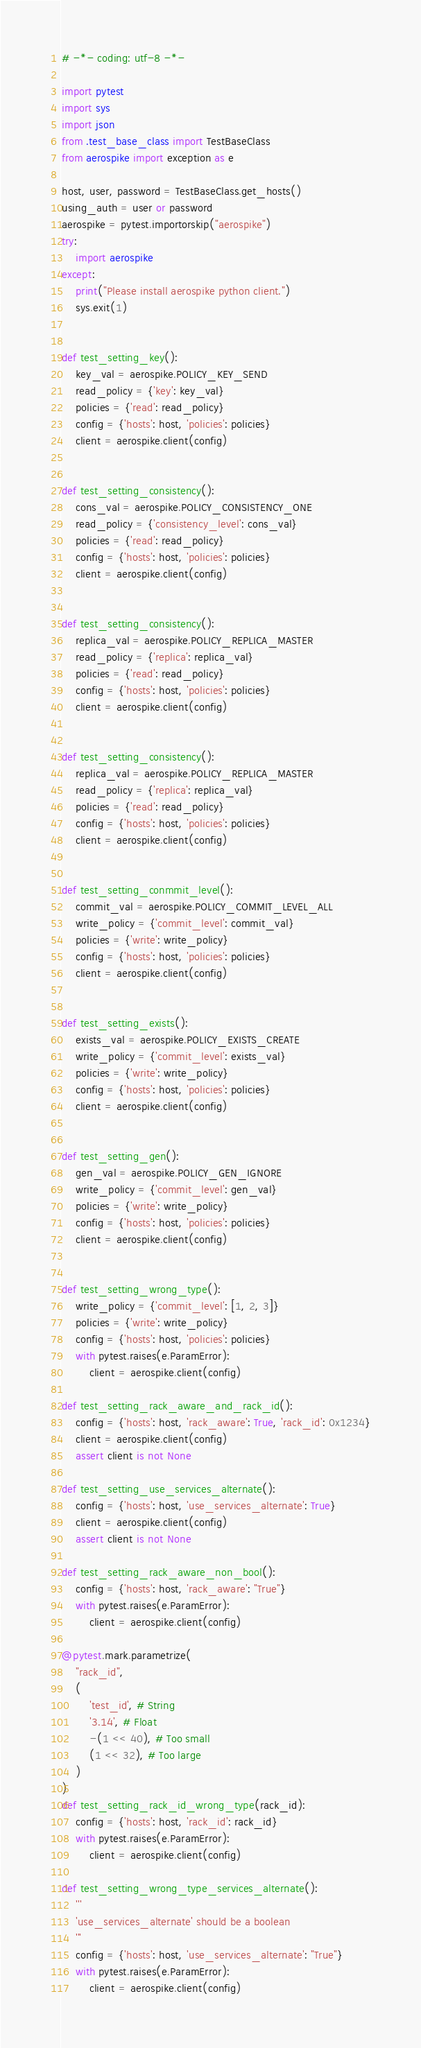<code> <loc_0><loc_0><loc_500><loc_500><_Python_># -*- coding: utf-8 -*-

import pytest
import sys
import json
from .test_base_class import TestBaseClass
from aerospike import exception as e

host, user, password = TestBaseClass.get_hosts()
using_auth = user or password
aerospike = pytest.importorskip("aerospike")
try:
    import aerospike
except:
    print("Please install aerospike python client.")
    sys.exit(1)


def test_setting_key():
    key_val = aerospike.POLICY_KEY_SEND
    read_policy = {'key': key_val}
    policies = {'read': read_policy}
    config = {'hosts': host, 'policies': policies}
    client = aerospike.client(config)


def test_setting_consistency():
    cons_val = aerospike.POLICY_CONSISTENCY_ONE
    read_policy = {'consistency_level': cons_val}
    policies = {'read': read_policy}
    config = {'hosts': host, 'policies': policies}
    client = aerospike.client(config)


def test_setting_consistency():
    replica_val = aerospike.POLICY_REPLICA_MASTER
    read_policy = {'replica': replica_val}
    policies = {'read': read_policy}
    config = {'hosts': host, 'policies': policies}
    client = aerospike.client(config)


def test_setting_consistency():
    replica_val = aerospike.POLICY_REPLICA_MASTER
    read_policy = {'replica': replica_val}
    policies = {'read': read_policy}
    config = {'hosts': host, 'policies': policies}
    client = aerospike.client(config)


def test_setting_conmmit_level():
    commit_val = aerospike.POLICY_COMMIT_LEVEL_ALL
    write_policy = {'commit_level': commit_val}
    policies = {'write': write_policy}
    config = {'hosts': host, 'policies': policies}
    client = aerospike.client(config)


def test_setting_exists():
    exists_val = aerospike.POLICY_EXISTS_CREATE
    write_policy = {'commit_level': exists_val}
    policies = {'write': write_policy}
    config = {'hosts': host, 'policies': policies}
    client = aerospike.client(config)


def test_setting_gen():
    gen_val = aerospike.POLICY_GEN_IGNORE
    write_policy = {'commit_level': gen_val}
    policies = {'write': write_policy}
    config = {'hosts': host, 'policies': policies}
    client = aerospike.client(config)


def test_setting_wrong_type():
    write_policy = {'commit_level': [1, 2, 3]}
    policies = {'write': write_policy}
    config = {'hosts': host, 'policies': policies}
    with pytest.raises(e.ParamError):
        client = aerospike.client(config)

def test_setting_rack_aware_and_rack_id():
    config = {'hosts': host, 'rack_aware': True, 'rack_id': 0x1234}
    client = aerospike.client(config)
    assert client is not None

def test_setting_use_services_alternate():
    config = {'hosts': host, 'use_services_alternate': True}
    client = aerospike.client(config)
    assert client is not None

def test_setting_rack_aware_non_bool():
    config = {'hosts': host, 'rack_aware': "True"}
    with pytest.raises(e.ParamError):
        client = aerospike.client(config)

@pytest.mark.parametrize(
    "rack_id",
    (
        'test_id', # String
        '3.14', # Float
        -(1 << 40), # Too small
        (1 << 32), # Too large
    )    
)
def test_setting_rack_id_wrong_type(rack_id):
    config = {'hosts': host, 'rack_id': rack_id}
    with pytest.raises(e.ParamError):
        client = aerospike.client(config)

def test_setting_wrong_type_services_alternate():
    '''
    'use_services_alternate' should be a boolean
    '''
    config = {'hosts': host, 'use_services_alternate': "True"}
    with pytest.raises(e.ParamError):
        client = aerospike.client(config)</code> 